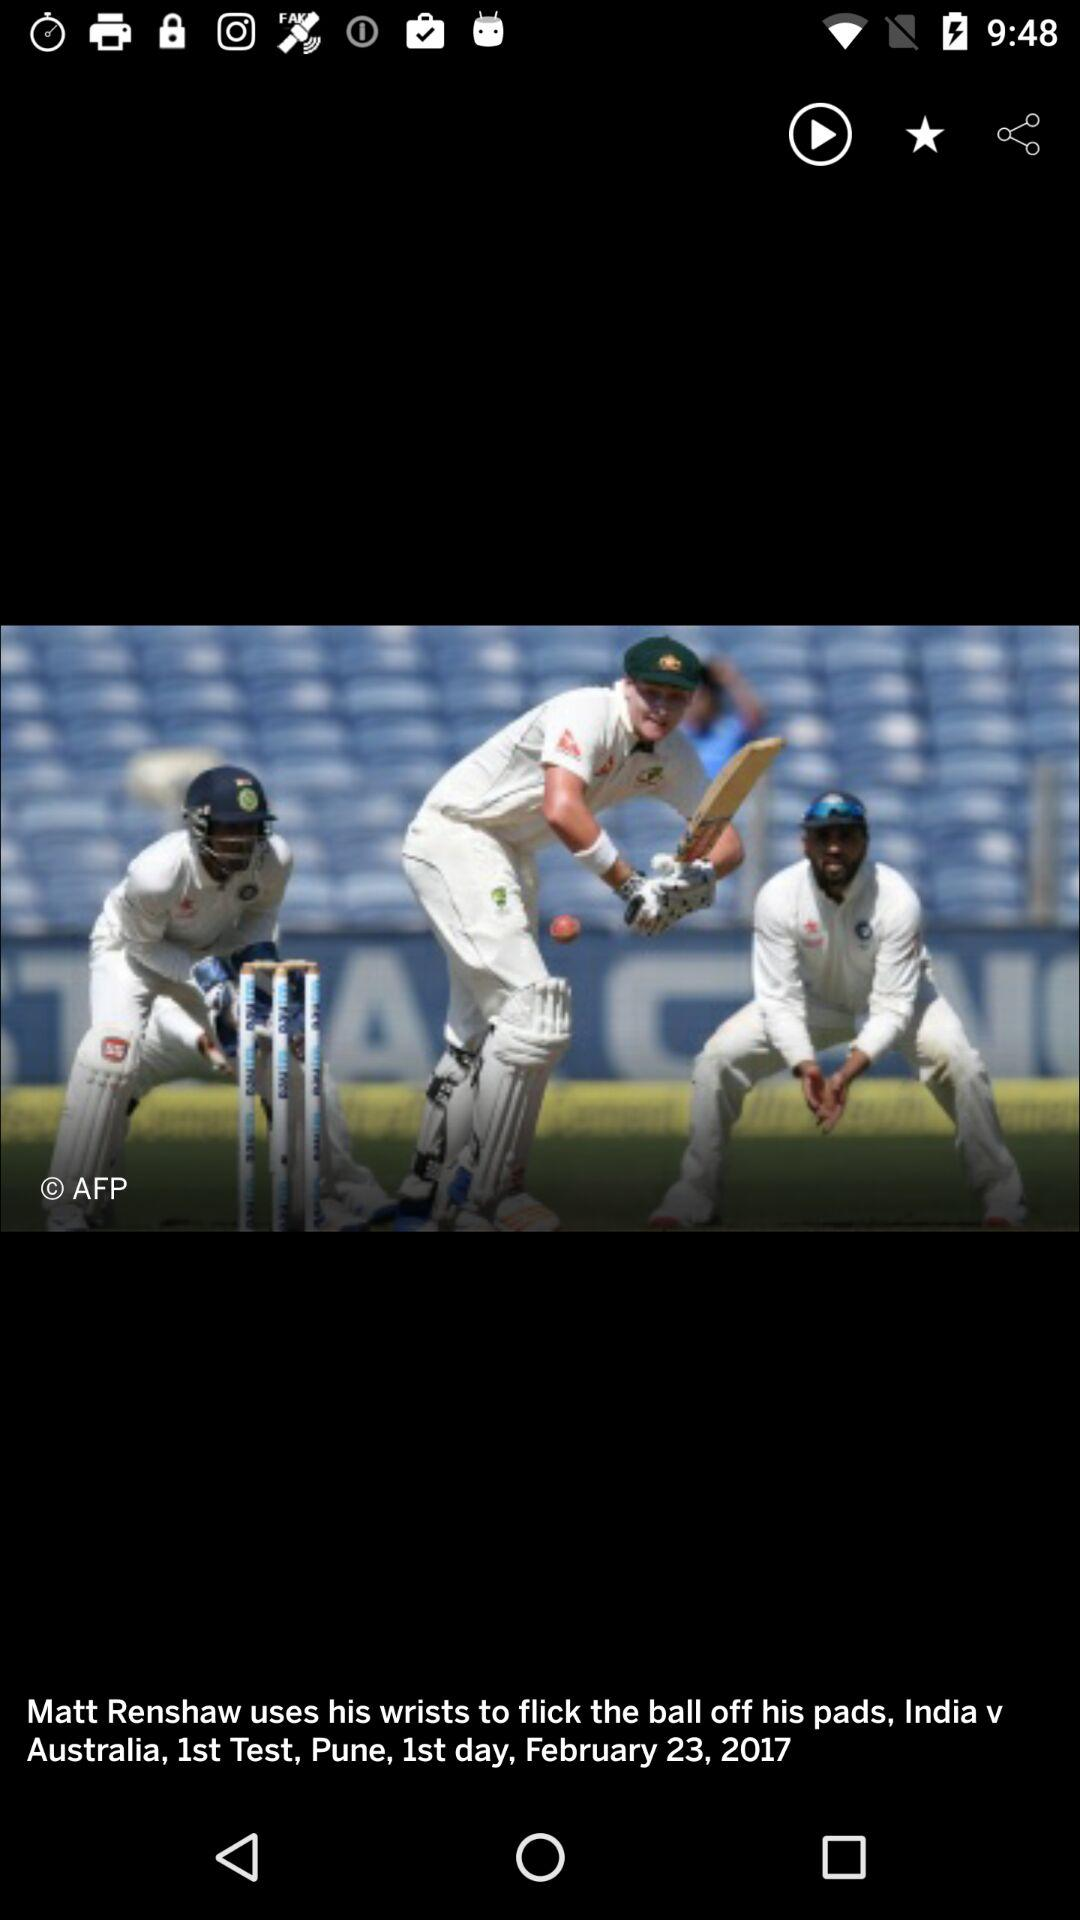What was the date of the first day of the match? The date of the first day of the match was February 23, 2017. 